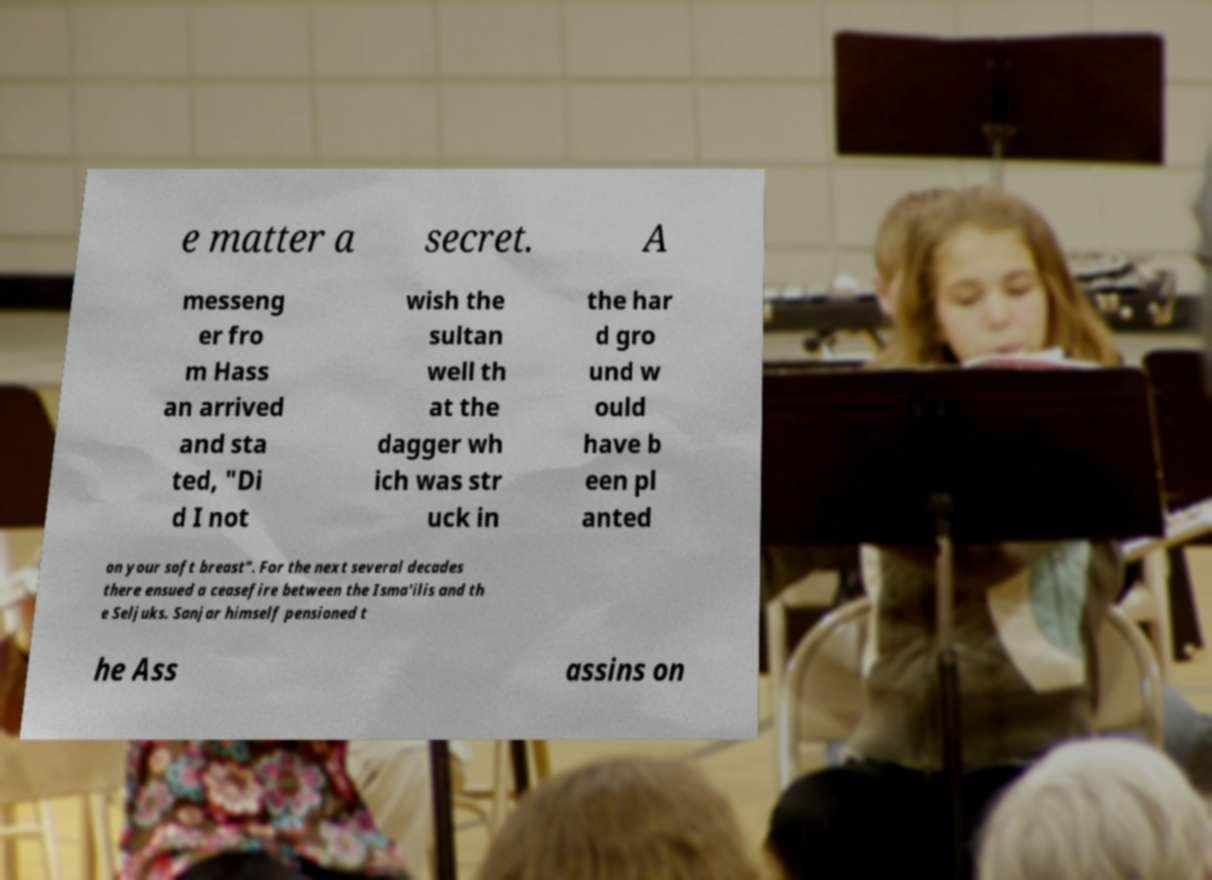For documentation purposes, I need the text within this image transcribed. Could you provide that? e matter a secret. A messeng er fro m Hass an arrived and sta ted, "Di d I not wish the sultan well th at the dagger wh ich was str uck in the har d gro und w ould have b een pl anted on your soft breast". For the next several decades there ensued a ceasefire between the Isma'ilis and th e Seljuks. Sanjar himself pensioned t he Ass assins on 